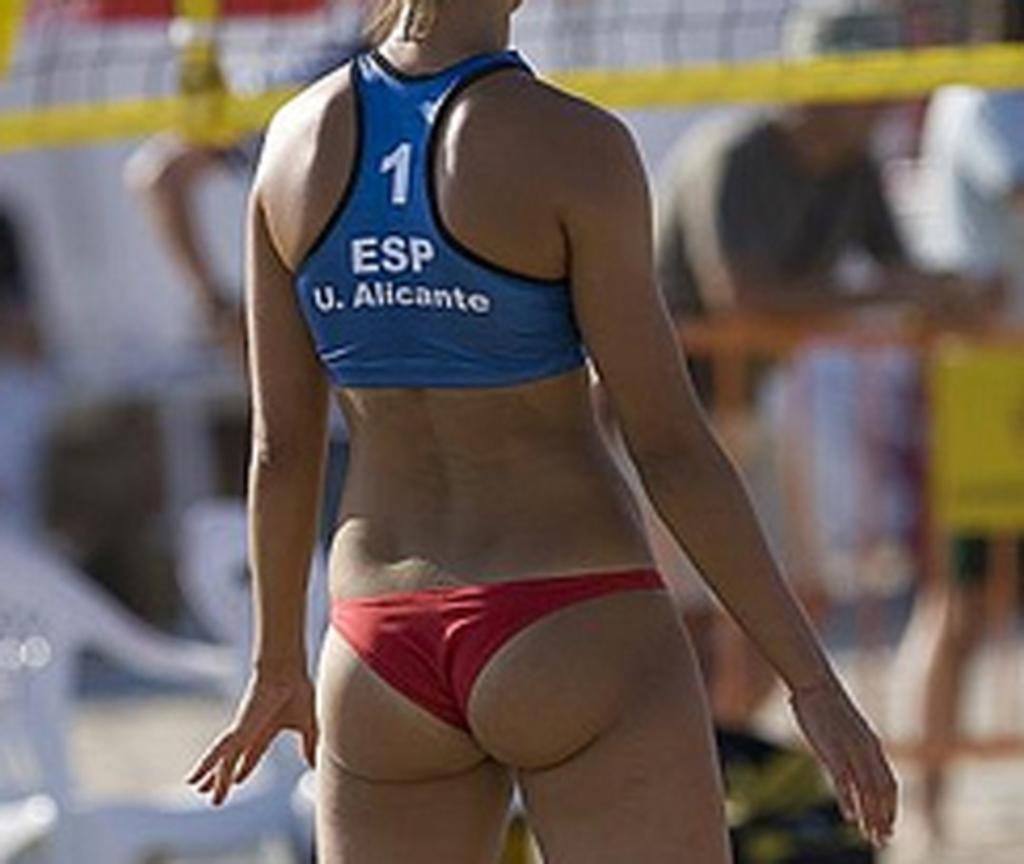What is the main subject of the image? There is a woman standing in the image. Can you describe the background of the image? The background of the image is blurred, and there are people and chairs visible. What type of tub is being used by the woman in the image? There is no tub present in the image; it features a woman standing with a blurred background. 